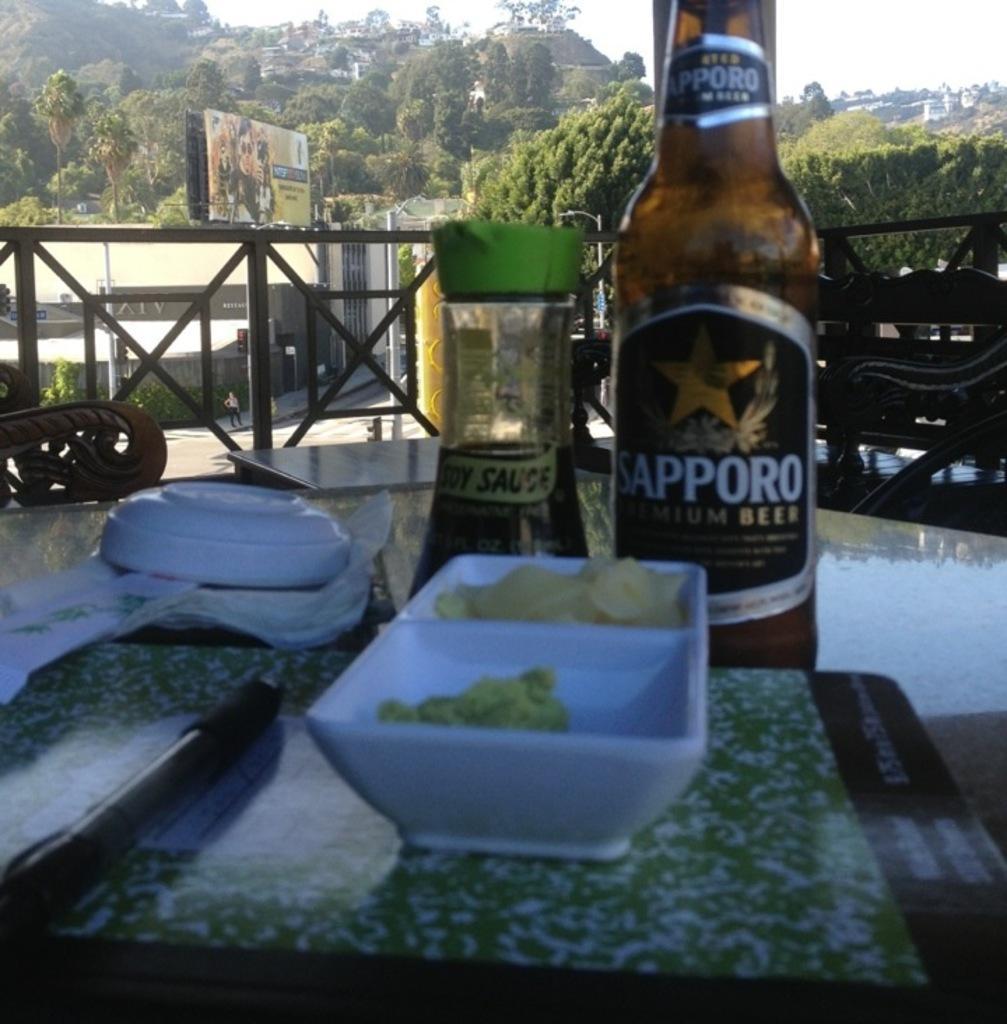In one or two sentences, can you explain what this image depicts? There is a table in the image. A book is placed on the table and above it a pen and two bowls are placed on it. In one of the bowel there are potato chips. There is also a beer bottle and a sauce bottle on the table. There are tissues and a plate reversed and kept on the table. There is a chair and a table just behind the front table. There is a road, pole and a building. There is a person standing on the sidewalk. There is a hoarding above the building. There are many trees in the background and also houses located on the hills. There is railing in the image. 